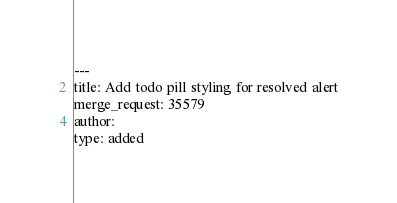<code> <loc_0><loc_0><loc_500><loc_500><_YAML_>---
title: Add todo pill styling for resolved alert
merge_request: 35579
author:
type: added
</code> 